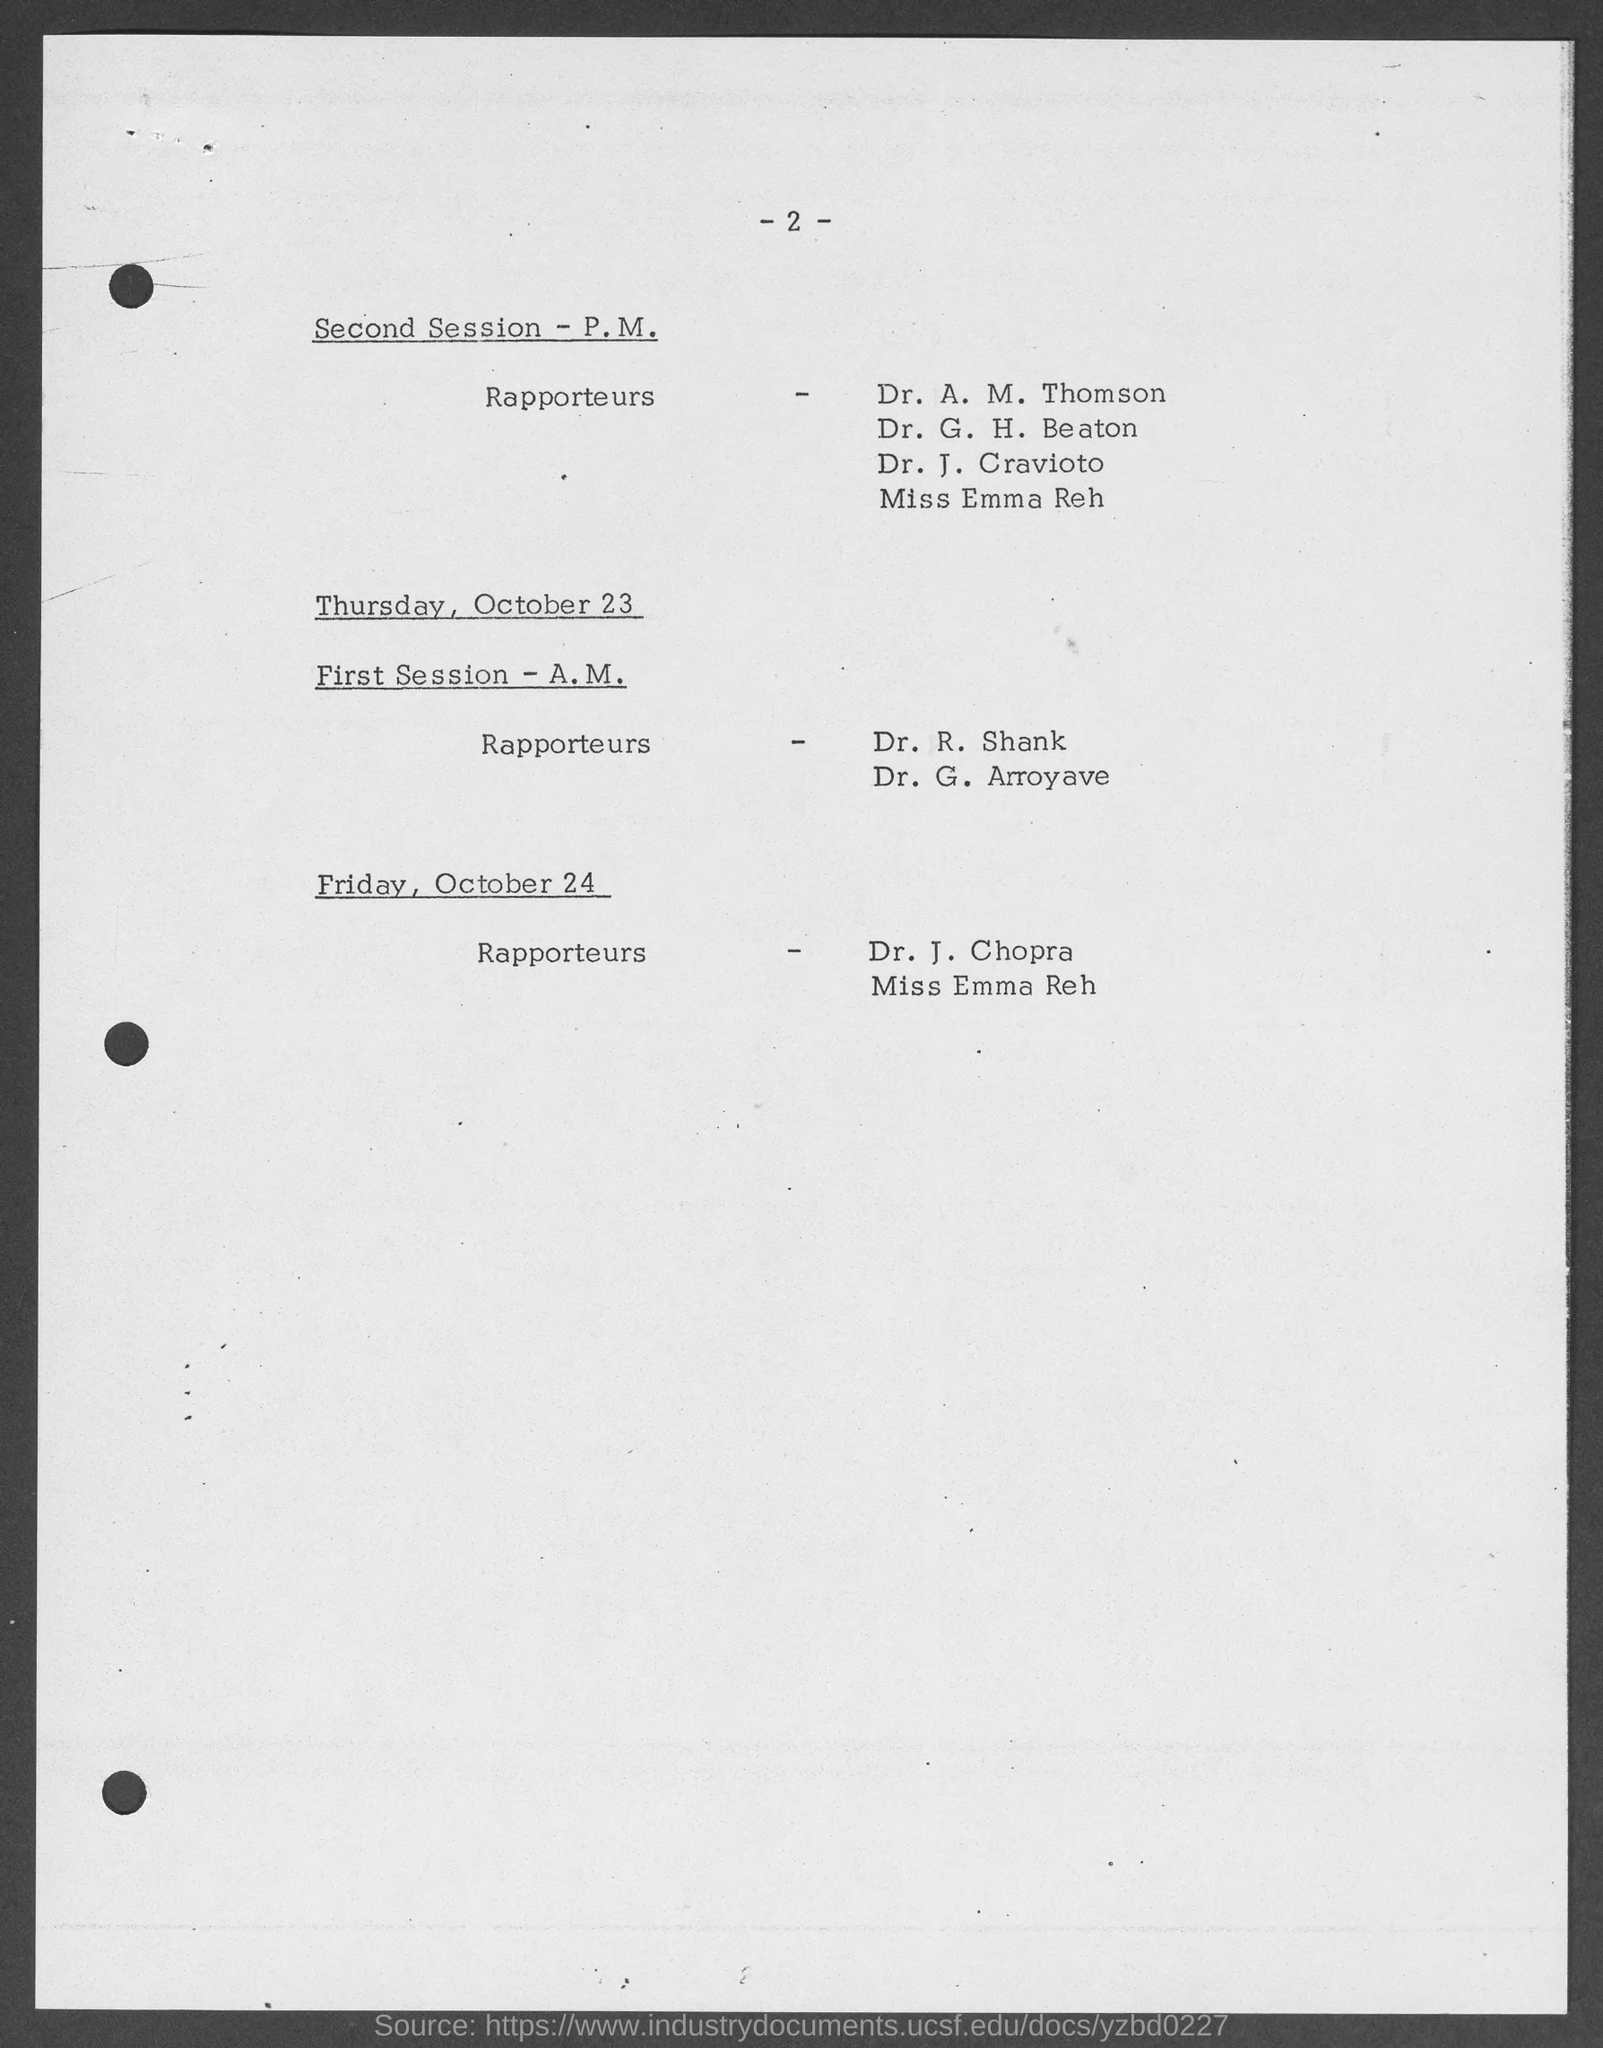Give some essential details in this illustration. On Friday, Dr. J. Chopra is the Rapporteur. The page number is 2. 